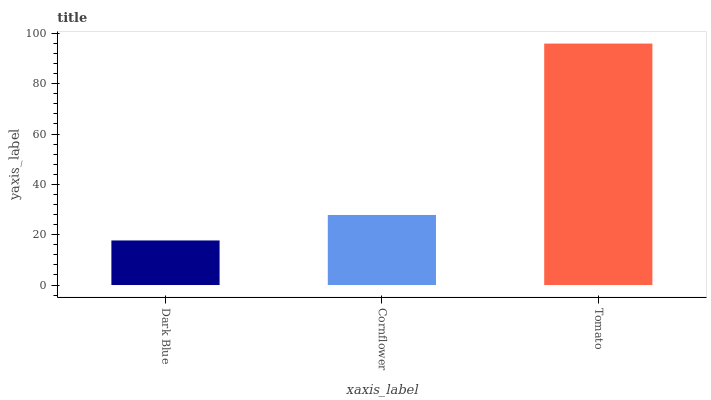Is Dark Blue the minimum?
Answer yes or no. Yes. Is Tomato the maximum?
Answer yes or no. Yes. Is Cornflower the minimum?
Answer yes or no. No. Is Cornflower the maximum?
Answer yes or no. No. Is Cornflower greater than Dark Blue?
Answer yes or no. Yes. Is Dark Blue less than Cornflower?
Answer yes or no. Yes. Is Dark Blue greater than Cornflower?
Answer yes or no. No. Is Cornflower less than Dark Blue?
Answer yes or no. No. Is Cornflower the high median?
Answer yes or no. Yes. Is Cornflower the low median?
Answer yes or no. Yes. Is Tomato the high median?
Answer yes or no. No. Is Tomato the low median?
Answer yes or no. No. 